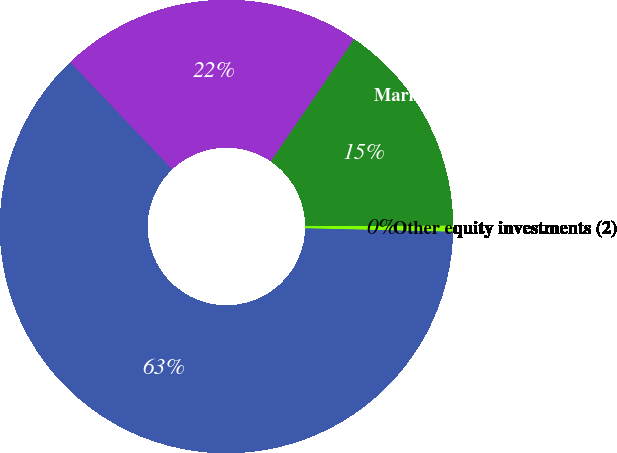Convert chart. <chart><loc_0><loc_0><loc_500><loc_500><pie_chart><fcel>Cash and cash equivalents<fcel>Marketable securities (1)<fcel>Other equity investments (2)<fcel>Long-term debt (4)<nl><fcel>21.63%<fcel>15.42%<fcel>0.43%<fcel>62.53%<nl></chart> 